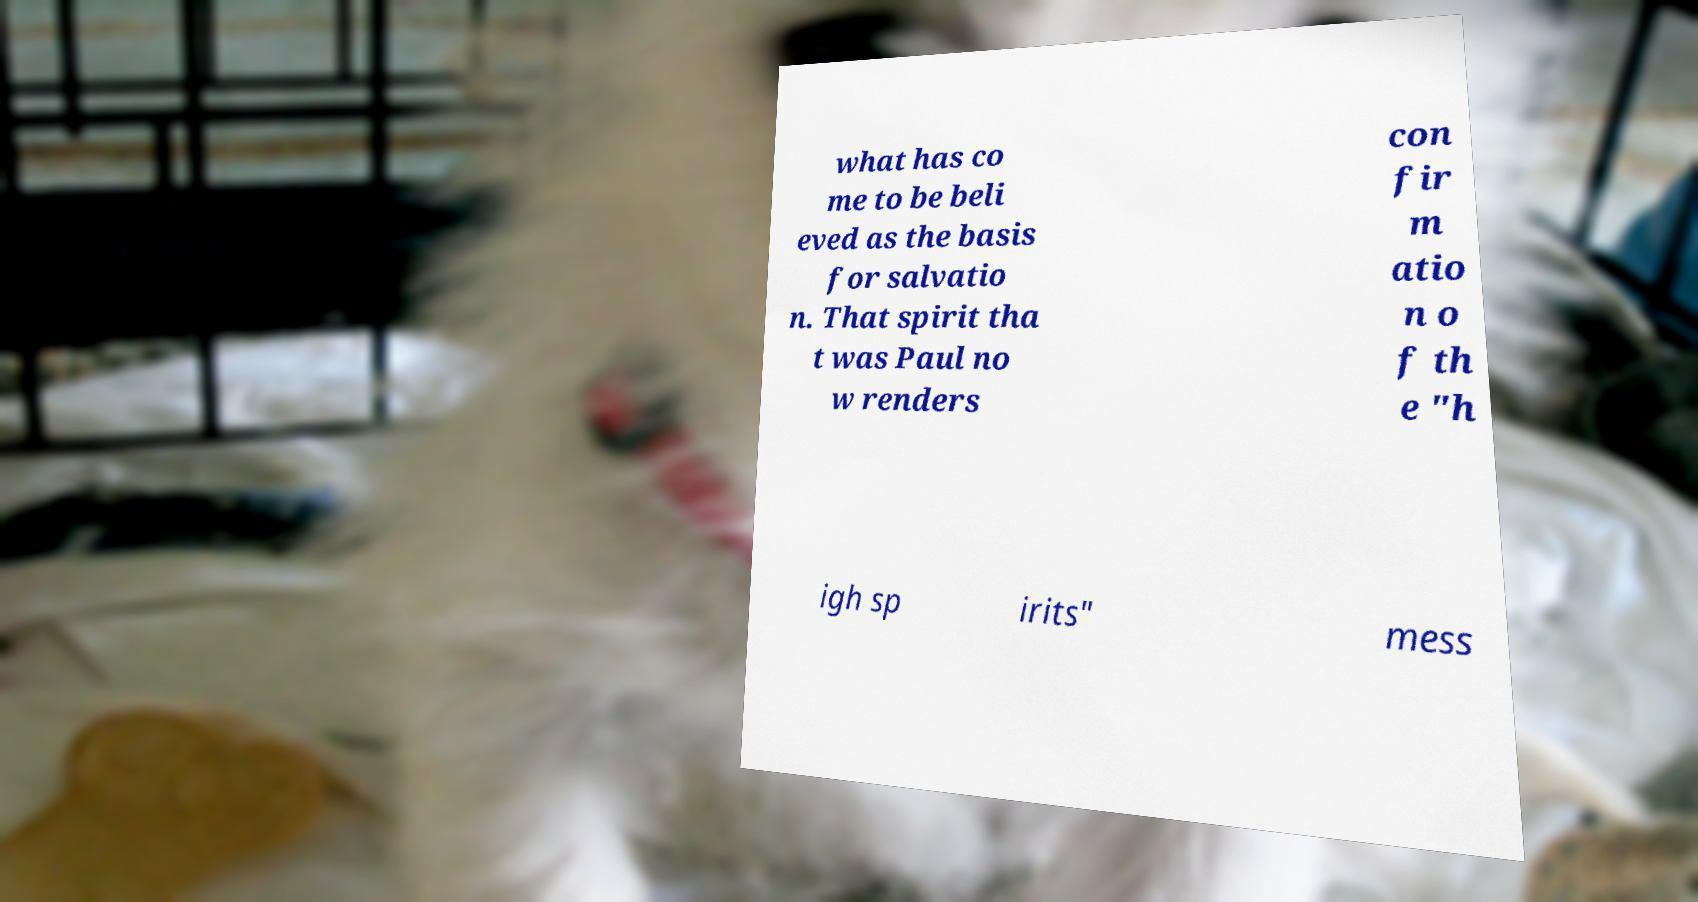Could you extract and type out the text from this image? what has co me to be beli eved as the basis for salvatio n. That spirit tha t was Paul no w renders con fir m atio n o f th e "h igh sp irits" mess 